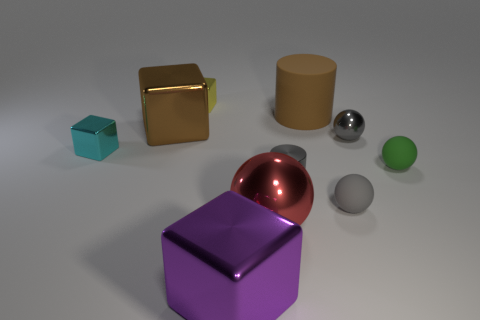There is another rubber thing that is the same shape as the small green object; what is its color?
Provide a short and direct response. Gray. Are there any other things that are the same shape as the yellow object?
Your response must be concise. Yes. Do the big block behind the big purple shiny thing and the tiny cylinder have the same color?
Your answer should be compact. No. The purple object that is the same shape as the yellow object is what size?
Your answer should be very brief. Large. What number of small green balls are the same material as the cyan block?
Keep it short and to the point. 0. Is there a gray metal cylinder right of the tiny gray object to the left of the rubber sphere in front of the small metal cylinder?
Offer a very short reply. No. There is a cyan metallic object; what shape is it?
Keep it short and to the point. Cube. Do the large block on the right side of the brown cube and the ball behind the cyan metallic block have the same material?
Give a very brief answer. Yes. How many things are the same color as the rubber cylinder?
Offer a very short reply. 1. What is the shape of the small metallic thing that is behind the cyan object and on the left side of the tiny gray metallic cylinder?
Offer a terse response. Cube. 